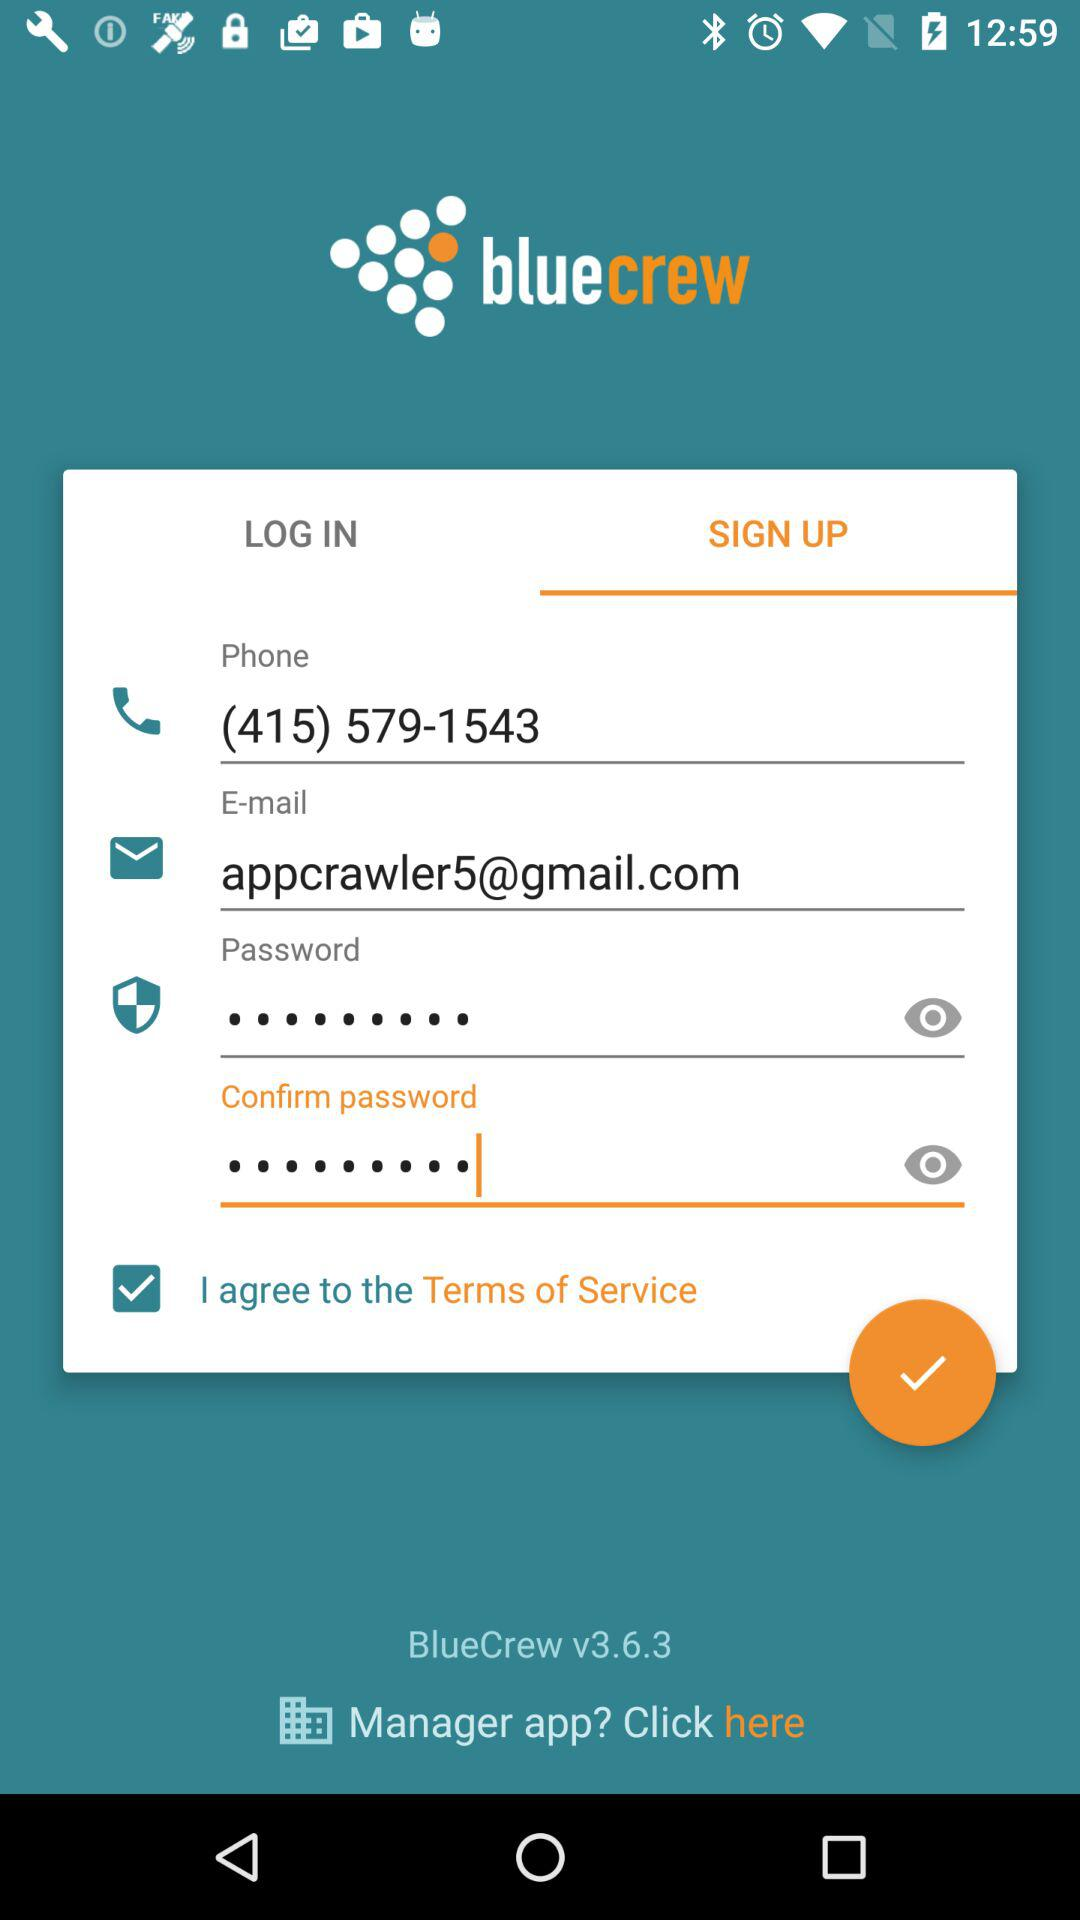What is the email address? The email address is appcrawler5@gmail.com. 